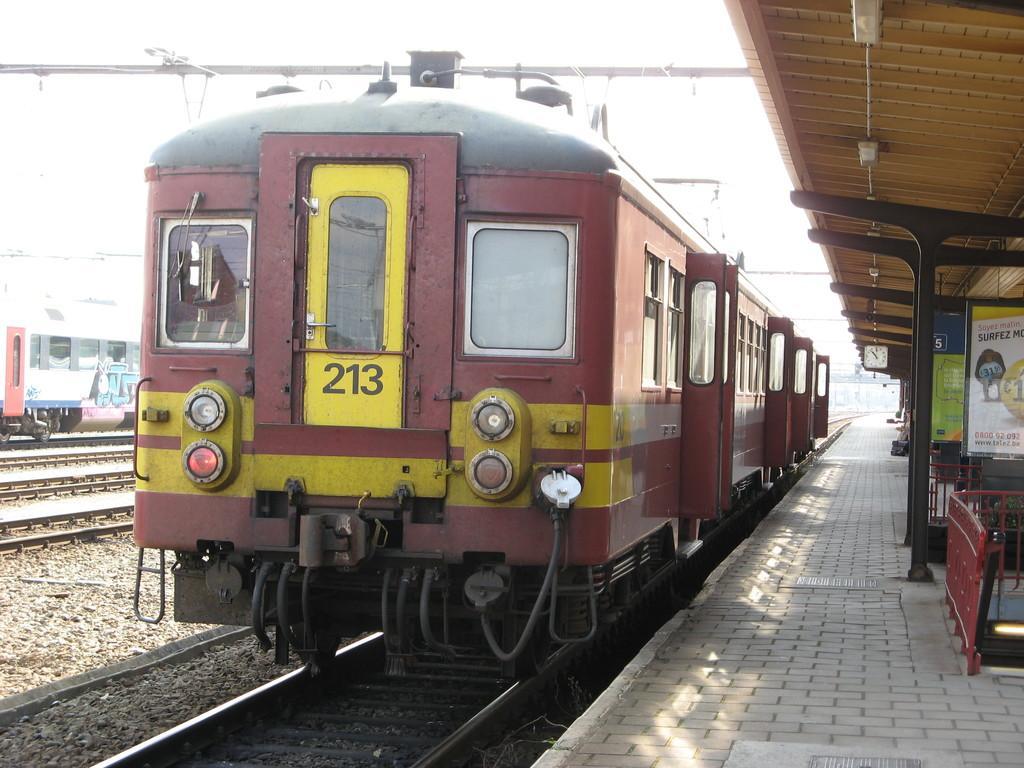In one or two sentences, can you explain what this image depicts? In this image there are trains on the rail track. On the platform there is a clock attached to the roof. There are few banners at the right side of image. Top of image there is sky. 